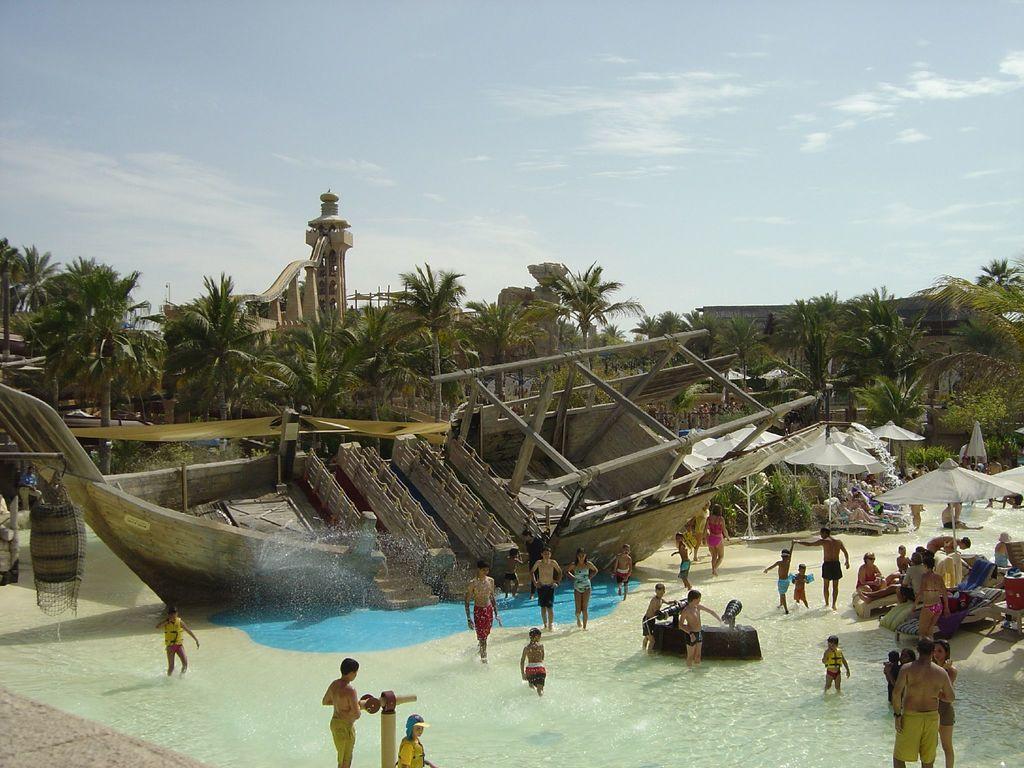Please provide a concise description of this image. In this picture we can see water at the bottom, there are some people standing in the water, on the right side there are benches and umbrellas, we can see a ship in the middle, in the background there are some trees, there is a barrel on the left side, we can see the sky at the top of the picture. 